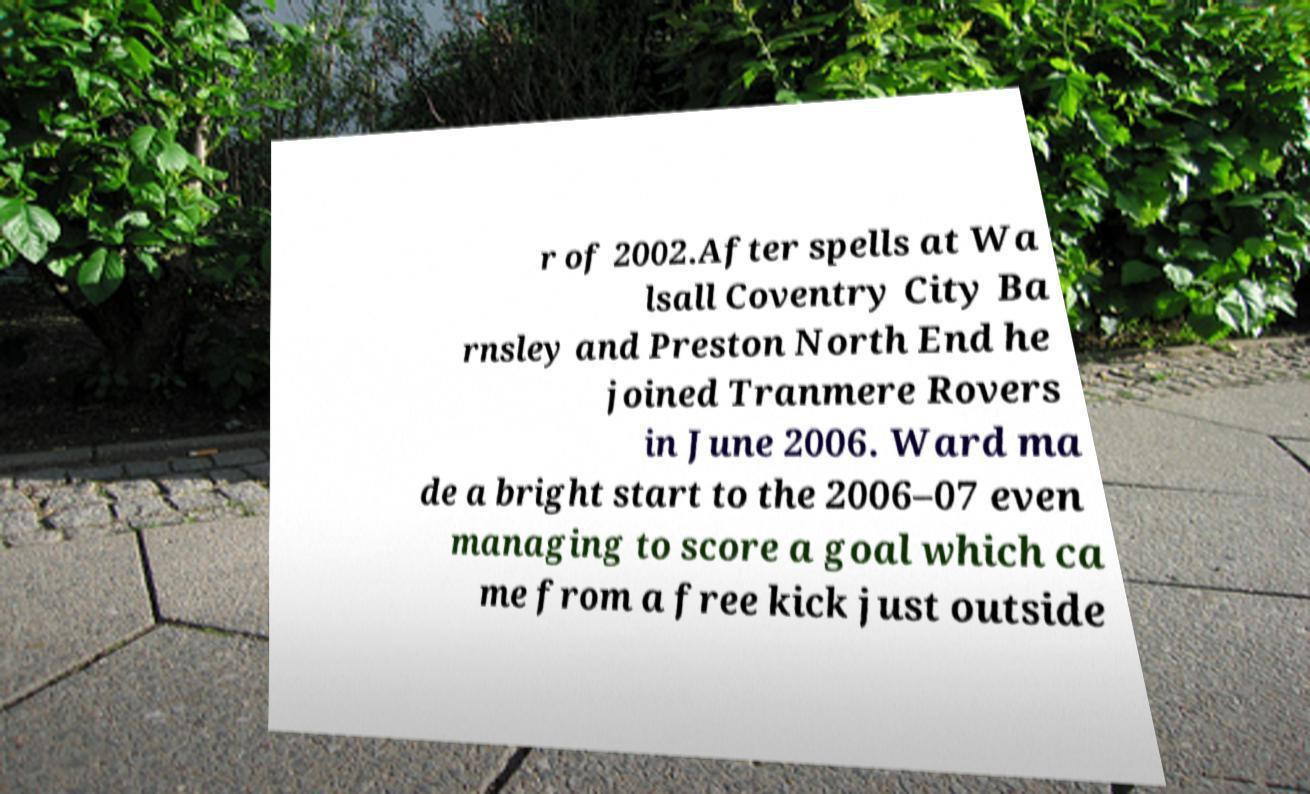There's text embedded in this image that I need extracted. Can you transcribe it verbatim? r of 2002.After spells at Wa lsall Coventry City Ba rnsley and Preston North End he joined Tranmere Rovers in June 2006. Ward ma de a bright start to the 2006–07 even managing to score a goal which ca me from a free kick just outside 